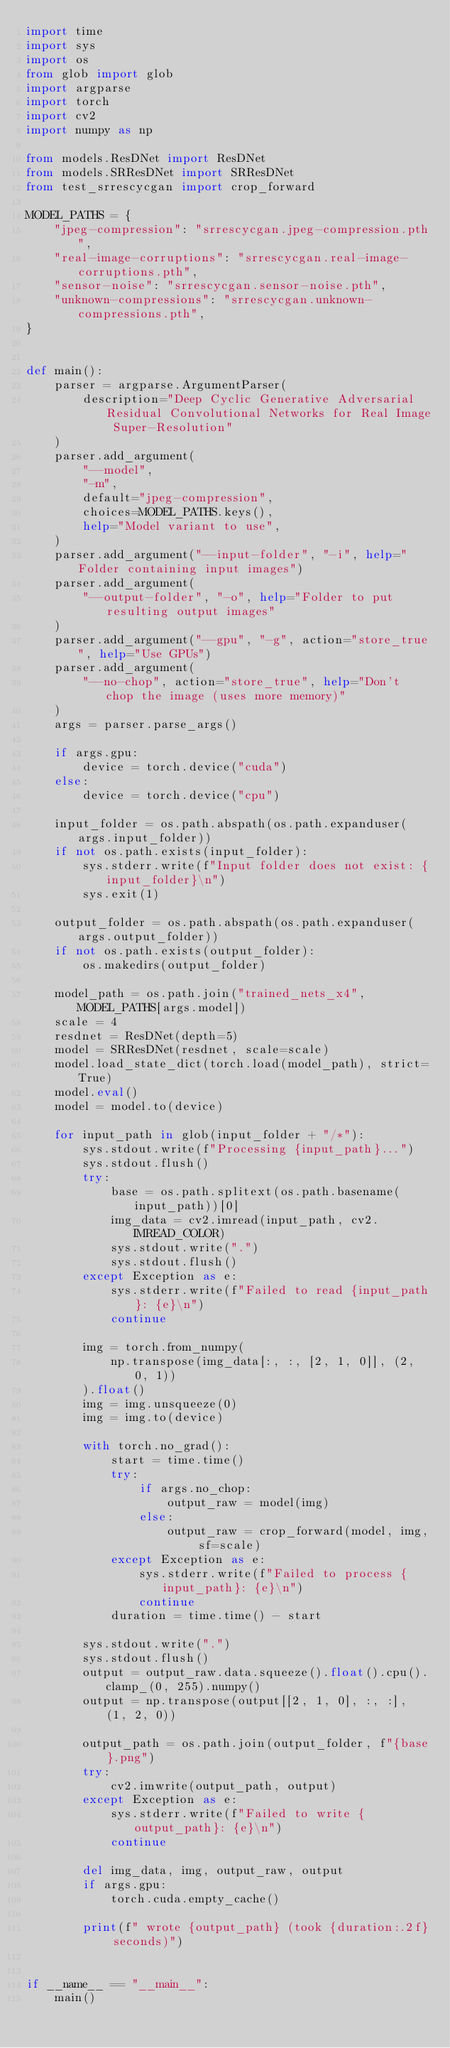Convert code to text. <code><loc_0><loc_0><loc_500><loc_500><_Python_>import time
import sys
import os
from glob import glob
import argparse
import torch
import cv2
import numpy as np

from models.ResDNet import ResDNet
from models.SRResDNet import SRResDNet
from test_srrescycgan import crop_forward

MODEL_PATHS = {
    "jpeg-compression": "srrescycgan.jpeg-compression.pth",
    "real-image-corruptions": "srrescycgan.real-image-corruptions.pth",
    "sensor-noise": "srrescycgan.sensor-noise.pth",
    "unknown-compressions": "srrescycgan.unknown-compressions.pth",
}


def main():
    parser = argparse.ArgumentParser(
        description="Deep Cyclic Generative Adversarial Residual Convolutional Networks for Real Image Super-Resolution"
    )
    parser.add_argument(
        "--model",
        "-m",
        default="jpeg-compression",
        choices=MODEL_PATHS.keys(),
        help="Model variant to use",
    )
    parser.add_argument("--input-folder", "-i", help="Folder containing input images")
    parser.add_argument(
        "--output-folder", "-o", help="Folder to put resulting output images"
    )
    parser.add_argument("--gpu", "-g", action="store_true", help="Use GPUs")
    parser.add_argument(
        "--no-chop", action="store_true", help="Don't chop the image (uses more memory)"
    )
    args = parser.parse_args()

    if args.gpu:
        device = torch.device("cuda")
    else:
        device = torch.device("cpu")

    input_folder = os.path.abspath(os.path.expanduser(args.input_folder))
    if not os.path.exists(input_folder):
        sys.stderr.write(f"Input folder does not exist: {input_folder}\n")
        sys.exit(1)

    output_folder = os.path.abspath(os.path.expanduser(args.output_folder))
    if not os.path.exists(output_folder):
        os.makedirs(output_folder)

    model_path = os.path.join("trained_nets_x4", MODEL_PATHS[args.model])
    scale = 4
    resdnet = ResDNet(depth=5)
    model = SRResDNet(resdnet, scale=scale)
    model.load_state_dict(torch.load(model_path), strict=True)
    model.eval()
    model = model.to(device)

    for input_path in glob(input_folder + "/*"):
        sys.stdout.write(f"Processing {input_path}...")
        sys.stdout.flush()
        try:
            base = os.path.splitext(os.path.basename(input_path))[0]
            img_data = cv2.imread(input_path, cv2.IMREAD_COLOR)
            sys.stdout.write(".")
            sys.stdout.flush()
        except Exception as e:
            sys.stderr.write(f"Failed to read {input_path}: {e}\n")
            continue

        img = torch.from_numpy(
            np.transpose(img_data[:, :, [2, 1, 0]], (2, 0, 1))
        ).float()
        img = img.unsqueeze(0)
        img = img.to(device)

        with torch.no_grad():
            start = time.time()
            try:
                if args.no_chop:
                    output_raw = model(img)
                else:
                    output_raw = crop_forward(model, img, sf=scale)
            except Exception as e:
                sys.stderr.write(f"Failed to process {input_path}: {e}\n")
                continue
            duration = time.time() - start

        sys.stdout.write(".")
        sys.stdout.flush()
        output = output_raw.data.squeeze().float().cpu().clamp_(0, 255).numpy()
        output = np.transpose(output[[2, 1, 0], :, :], (1, 2, 0))

        output_path = os.path.join(output_folder, f"{base}.png")
        try:
            cv2.imwrite(output_path, output)
        except Exception as e:
            sys.stderr.write(f"Failed to write {output_path}: {e}\n")
            continue

        del img_data, img, output_raw, output
        if args.gpu:
            torch.cuda.empty_cache()

        print(f" wrote {output_path} (took {duration:.2f} seconds)")


if __name__ == "__main__":
    main()
</code> 